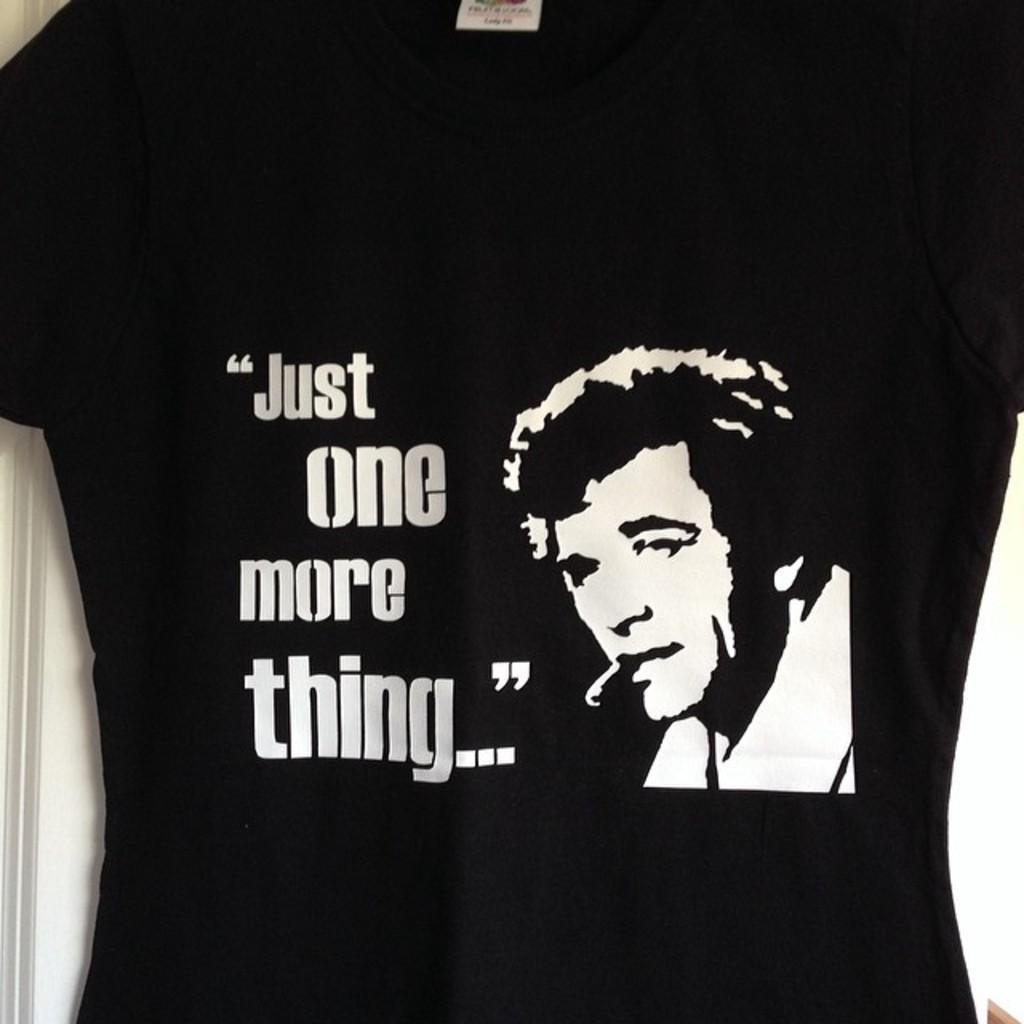Please provide a concise description of this image. In this image we can see a black shirt, here is the person, here is the matter written on it. 